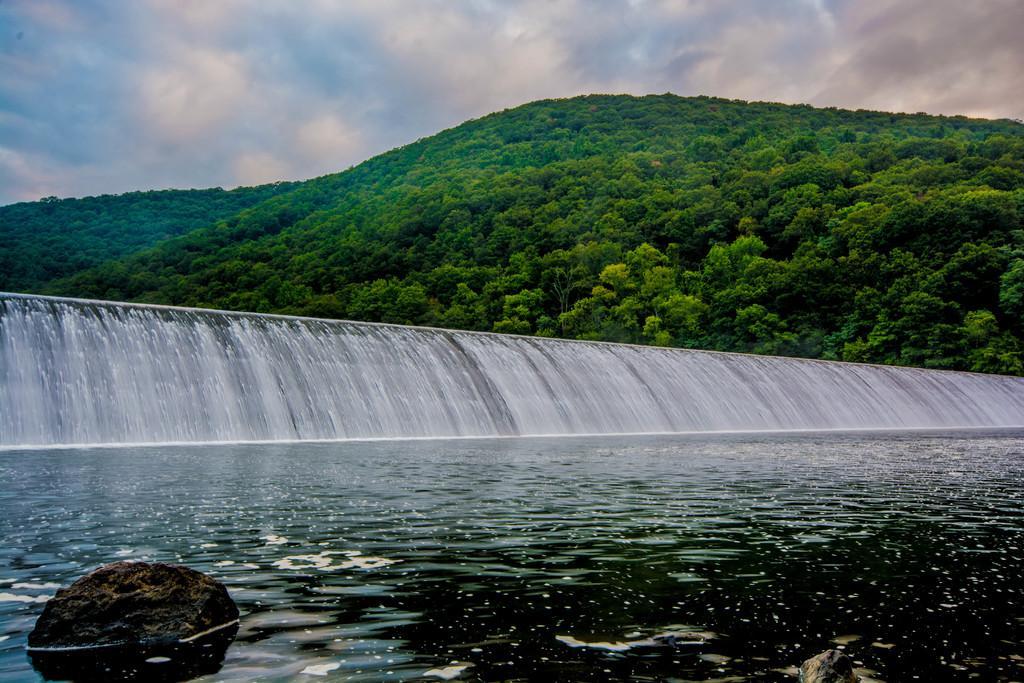Describe this image in one or two sentences. In this image I can see the water flowing. In the background I can see few trees. In the bottom left hand corner I can see the stone. At the top I can see clouds in the sky. 